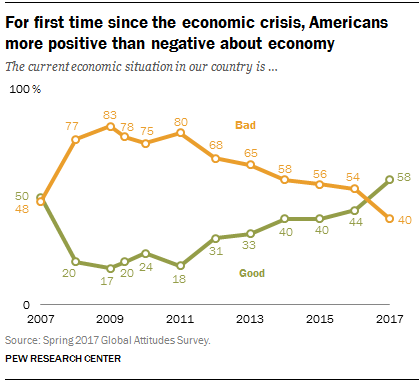Highlight a few significant elements in this photo. Out of the bad values that were below 56%, there were 3 of them. The current economic situation in our country was at its best in 2017. 